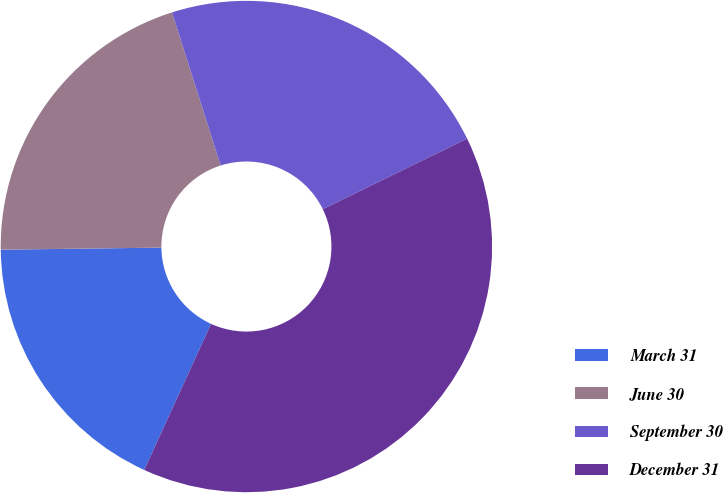Convert chart. <chart><loc_0><loc_0><loc_500><loc_500><pie_chart><fcel>March 31<fcel>June 30<fcel>September 30<fcel>December 31<nl><fcel>17.97%<fcel>20.31%<fcel>22.66%<fcel>39.06%<nl></chart> 